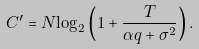<formula> <loc_0><loc_0><loc_500><loc_500>{ C ^ { \prime } } = N { \log _ { 2 } } \left ( { 1 + \frac { T } { { \alpha q + { \sigma ^ { 2 } } } } } \right ) .</formula> 